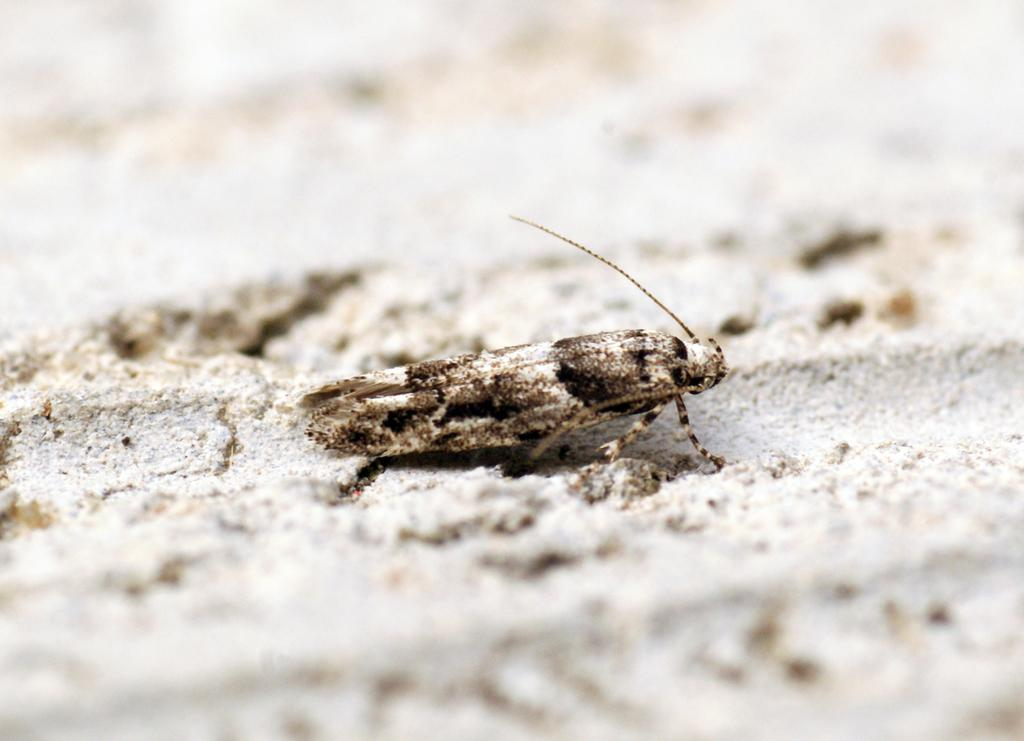What type of creature can be seen in the image? There is an insect in the image. Where is the insect located in the image? The insect is on a surface. What type of cushion is being selected by the insect in the image? There is no cushion present in the image, and the insect is not selecting anything. 